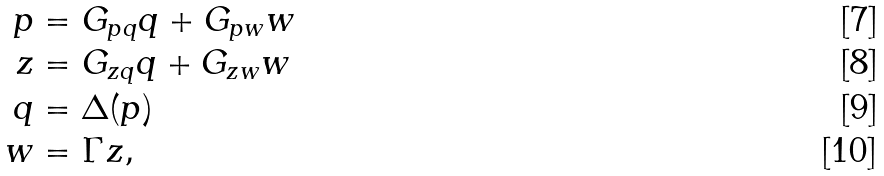<formula> <loc_0><loc_0><loc_500><loc_500>p & = G _ { p q } q + G _ { p w } w \\ z & = G _ { z q } q + G _ { z w } w \\ q & = \Delta ( p ) \\ w & = \Gamma z ,</formula> 